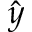Convert formula to latex. <formula><loc_0><loc_0><loc_500><loc_500>\hat { y }</formula> 